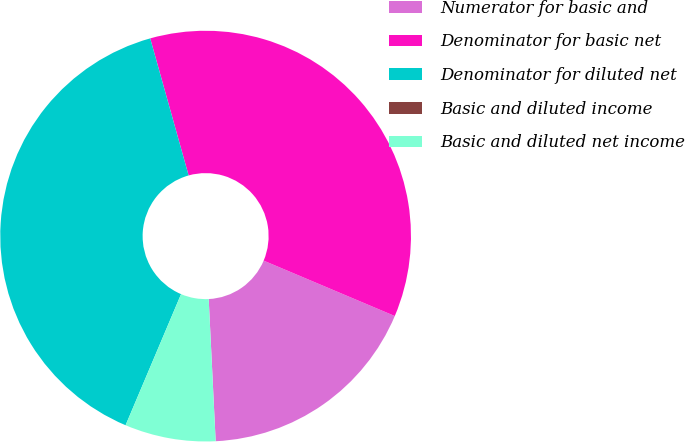<chart> <loc_0><loc_0><loc_500><loc_500><pie_chart><fcel>Numerator for basic and<fcel>Denominator for basic net<fcel>Denominator for diluted net<fcel>Basic and diluted income<fcel>Basic and diluted net income<nl><fcel>17.86%<fcel>35.71%<fcel>39.28%<fcel>0.0%<fcel>7.15%<nl></chart> 